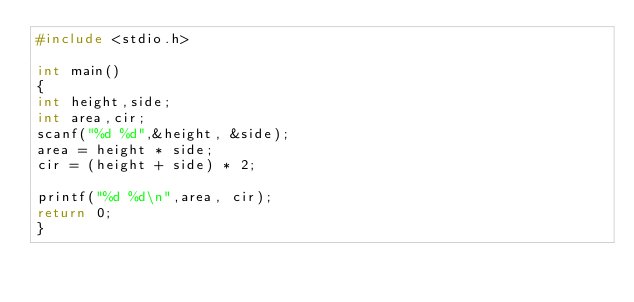Convert code to text. <code><loc_0><loc_0><loc_500><loc_500><_C_>#include <stdio.h>
 
int main()
{
int height,side;
int area,cir;
scanf("%d %d",&height, &side);
area = height * side;
cir = (height + side) * 2;
 
printf("%d %d\n",area, cir);
return 0;
}</code> 